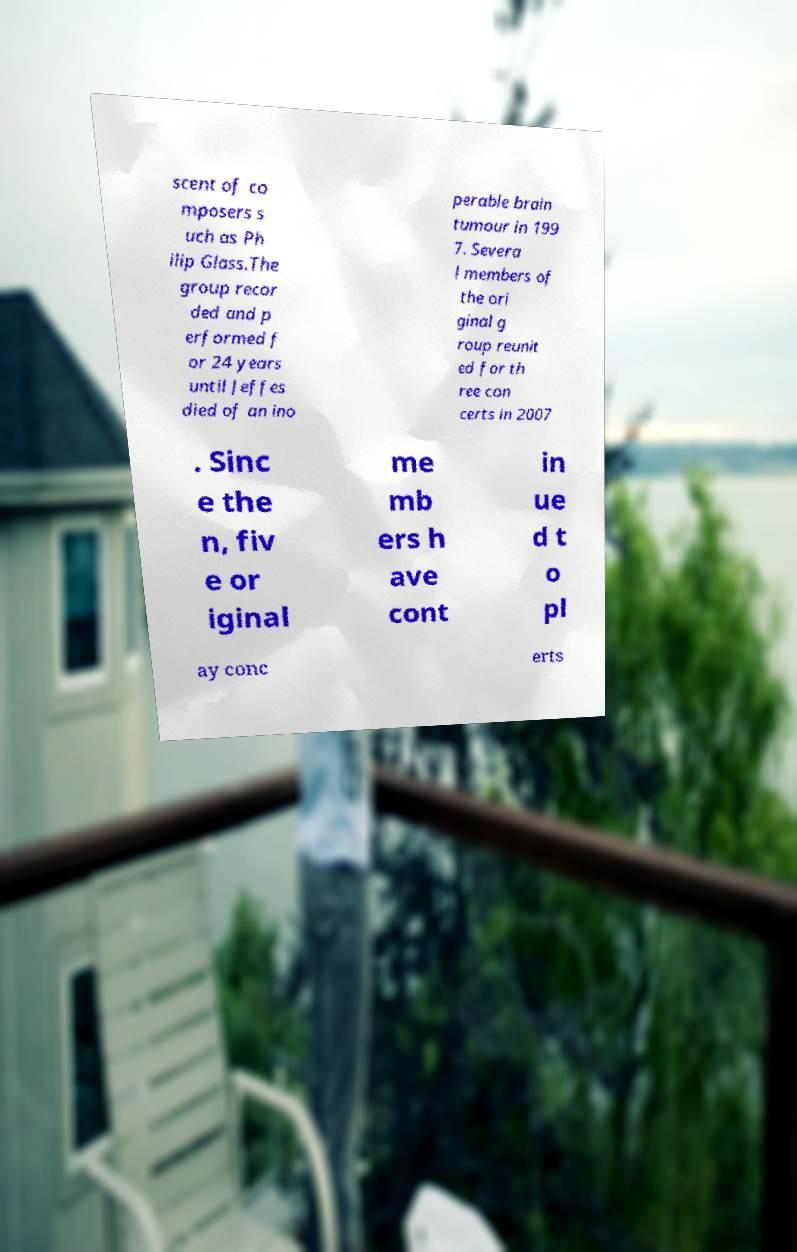For documentation purposes, I need the text within this image transcribed. Could you provide that? scent of co mposers s uch as Ph ilip Glass.The group recor ded and p erformed f or 24 years until Jeffes died of an ino perable brain tumour in 199 7. Severa l members of the ori ginal g roup reunit ed for th ree con certs in 2007 . Sinc e the n, fiv e or iginal me mb ers h ave cont in ue d t o pl ay conc erts 